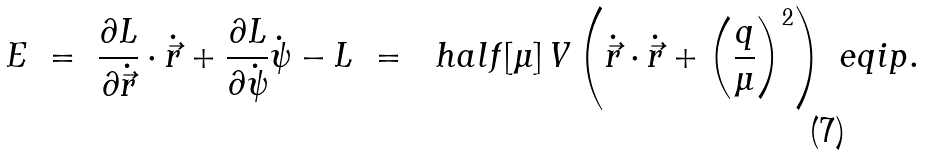Convert formula to latex. <formula><loc_0><loc_0><loc_500><loc_500>E & \ = \ \frac { \partial L } { \partial \dot { \vec { r } } } \cdot \dot { \vec { r } } + \frac { \partial L } { \partial \dot { \psi } } \dot { \psi } - L \ = \ \ h a l f [ \mu ] \, V \left ( \dot { \vec { r } } \cdot \dot { \vec { r } } + \left ( \frac { q } { \mu } \right ) ^ { 2 } \right ) \ e q i p { . }</formula> 